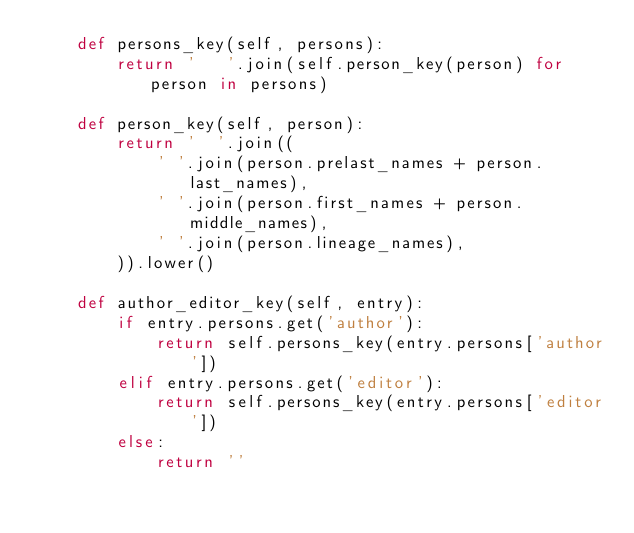Convert code to text. <code><loc_0><loc_0><loc_500><loc_500><_Python_>    def persons_key(self, persons):
        return '   '.join(self.person_key(person) for person in persons)

    def person_key(self, person):
        return '  '.join((
            ' '.join(person.prelast_names + person.last_names),
            ' '.join(person.first_names + person.middle_names),
            ' '.join(person.lineage_names),
        )).lower()

    def author_editor_key(self, entry):
        if entry.persons.get('author'):
            return self.persons_key(entry.persons['author'])
        elif entry.persons.get('editor'):
            return self.persons_key(entry.persons['editor'])
        else:
            return ''
</code> 